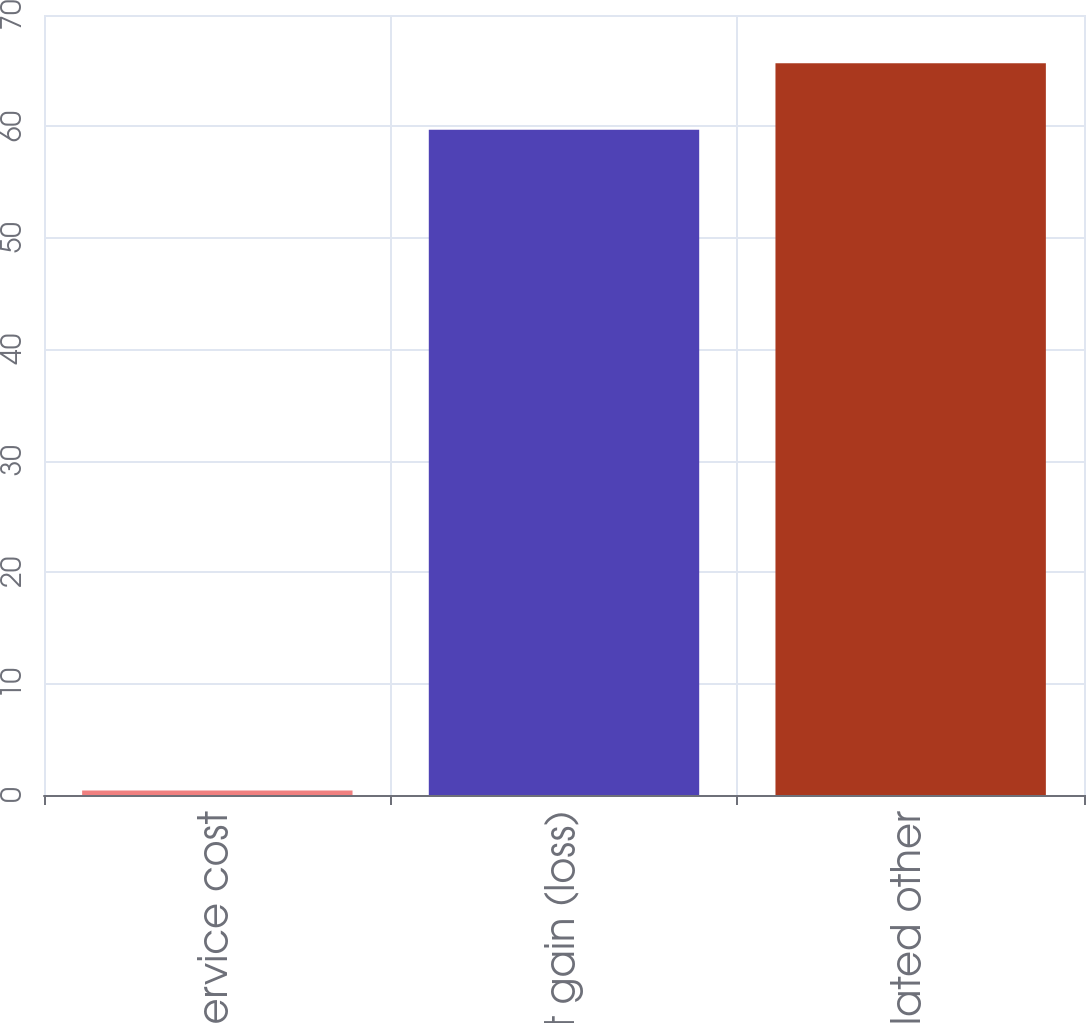Convert chart. <chart><loc_0><loc_0><loc_500><loc_500><bar_chart><fcel>Prior service cost<fcel>Net gain (loss)<fcel>Accumulated other<nl><fcel>0.4<fcel>59.7<fcel>65.67<nl></chart> 